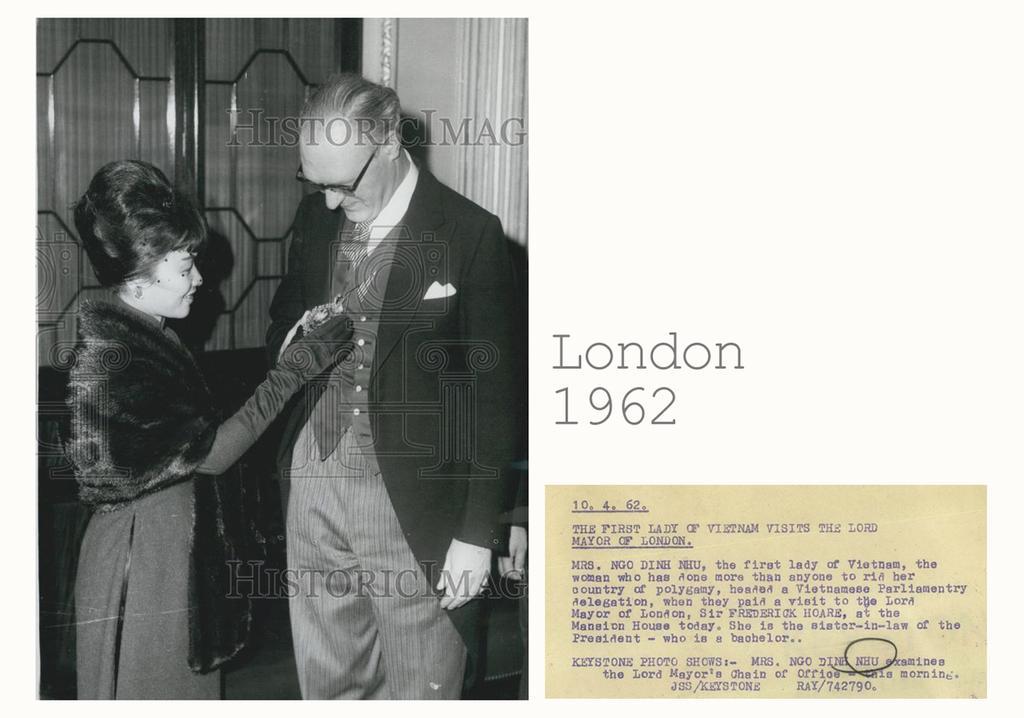Could you give a brief overview of what you see in this image? This is an edited picture. I can see a man and a woman standing, there are watermarks on the image, on the right side of the image it looks like a letter with some words and numbers on it. 